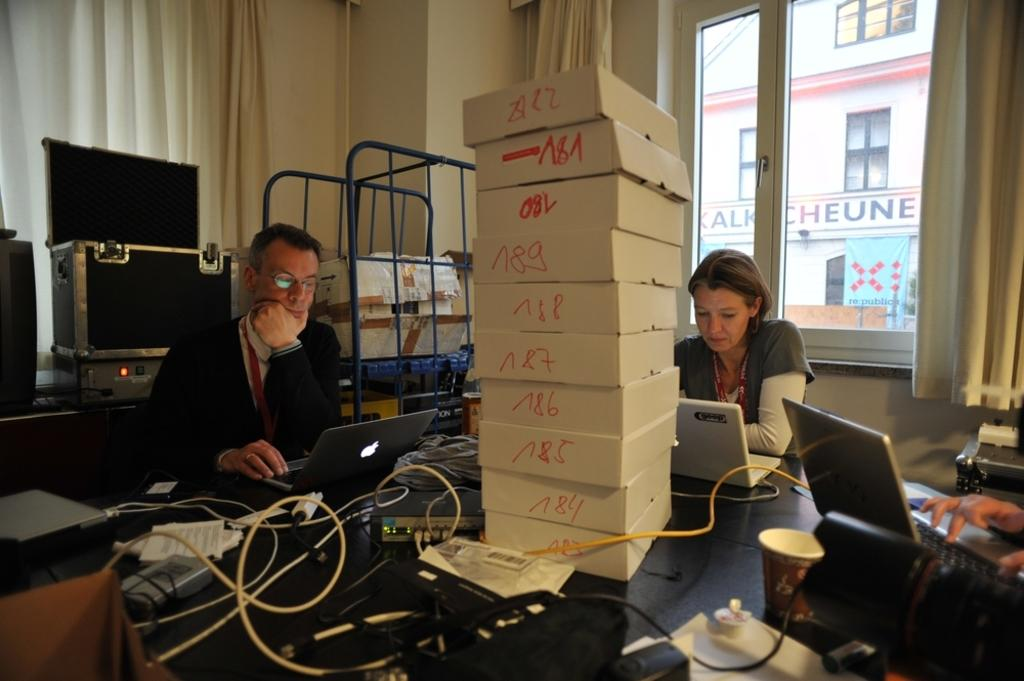<image>
Offer a succinct explanation of the picture presented. A man and a women with white boxes that have numbers 83 to 89 written on the side. 